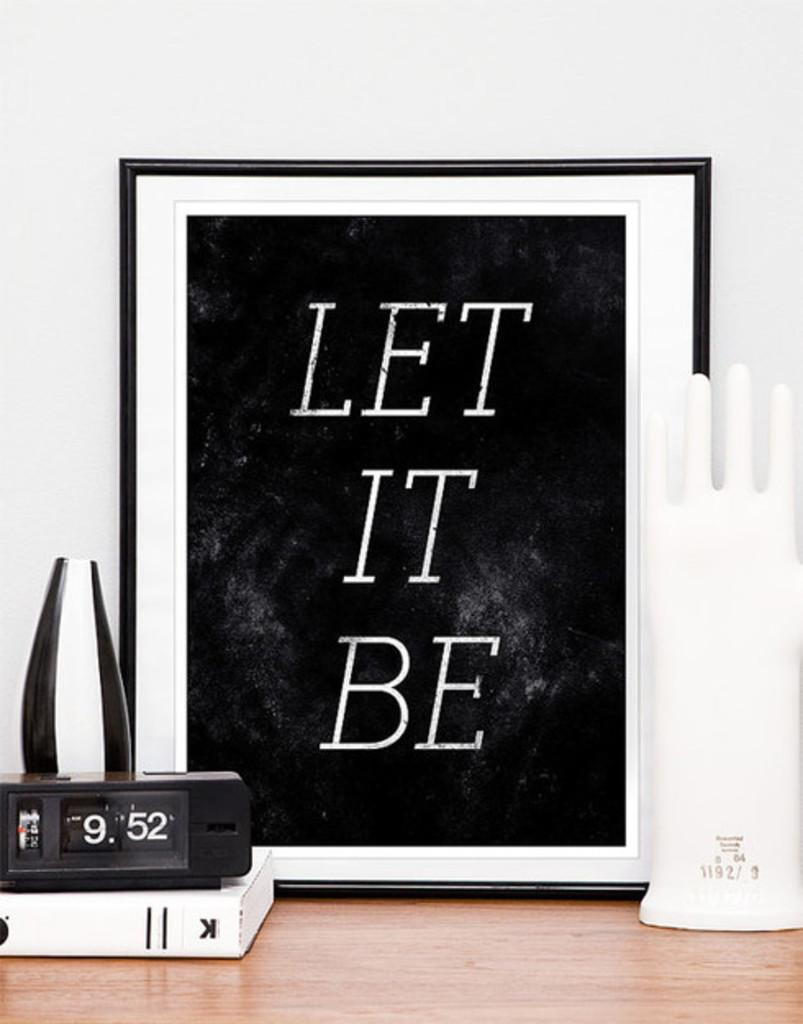Provide a one-sentence caption for the provided image. A Let It Be poster is framed in a black frame. 